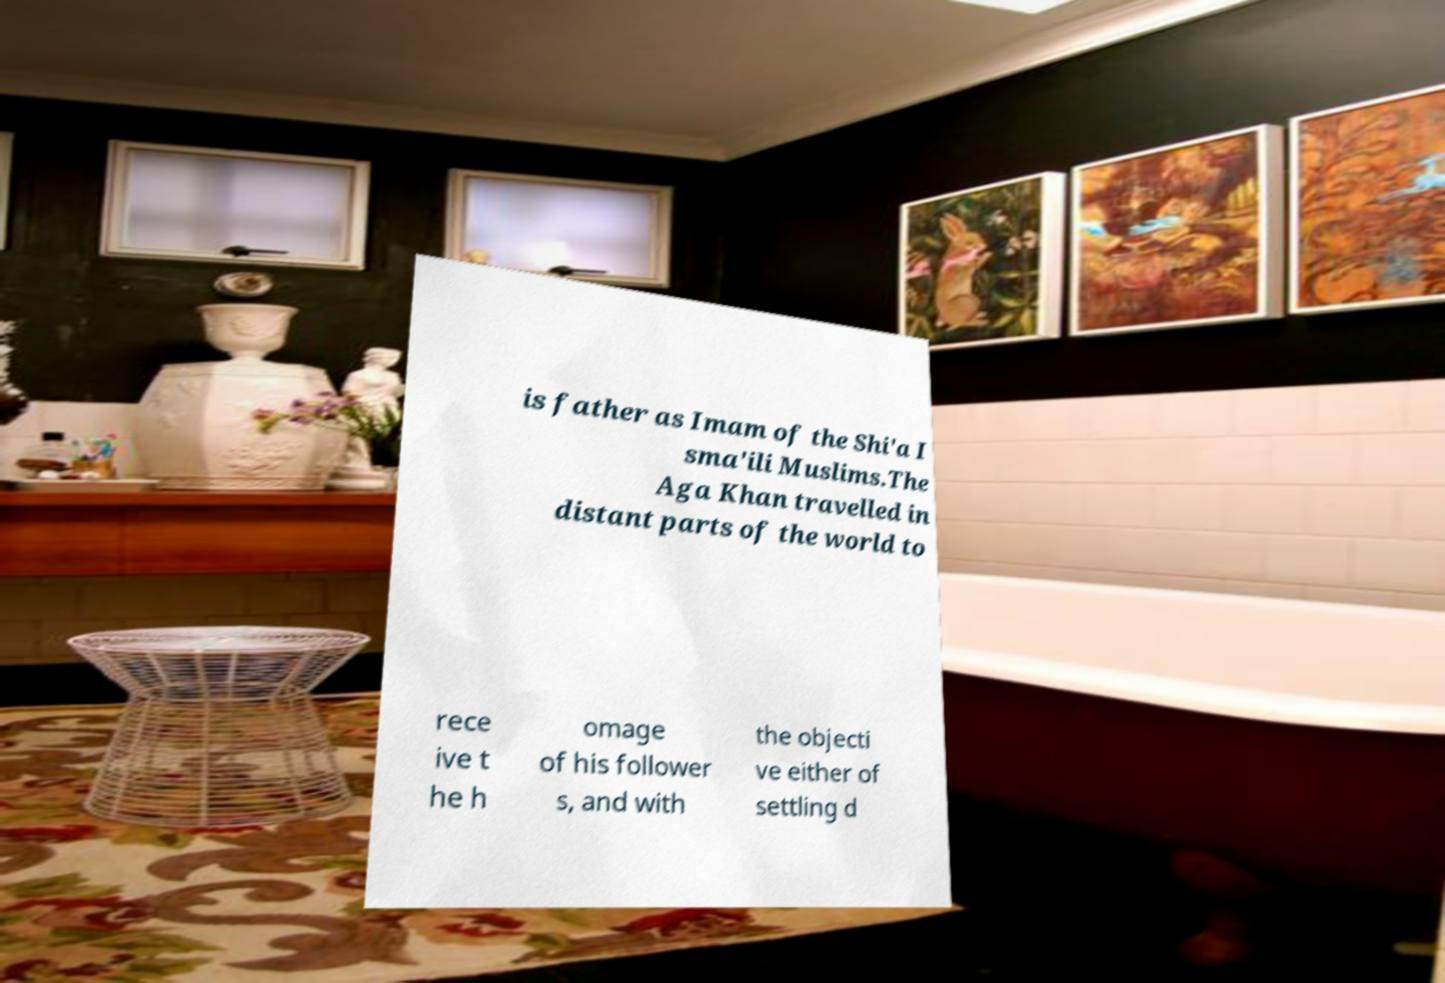For documentation purposes, I need the text within this image transcribed. Could you provide that? is father as Imam of the Shi'a I sma'ili Muslims.The Aga Khan travelled in distant parts of the world to rece ive t he h omage of his follower s, and with the objecti ve either of settling d 